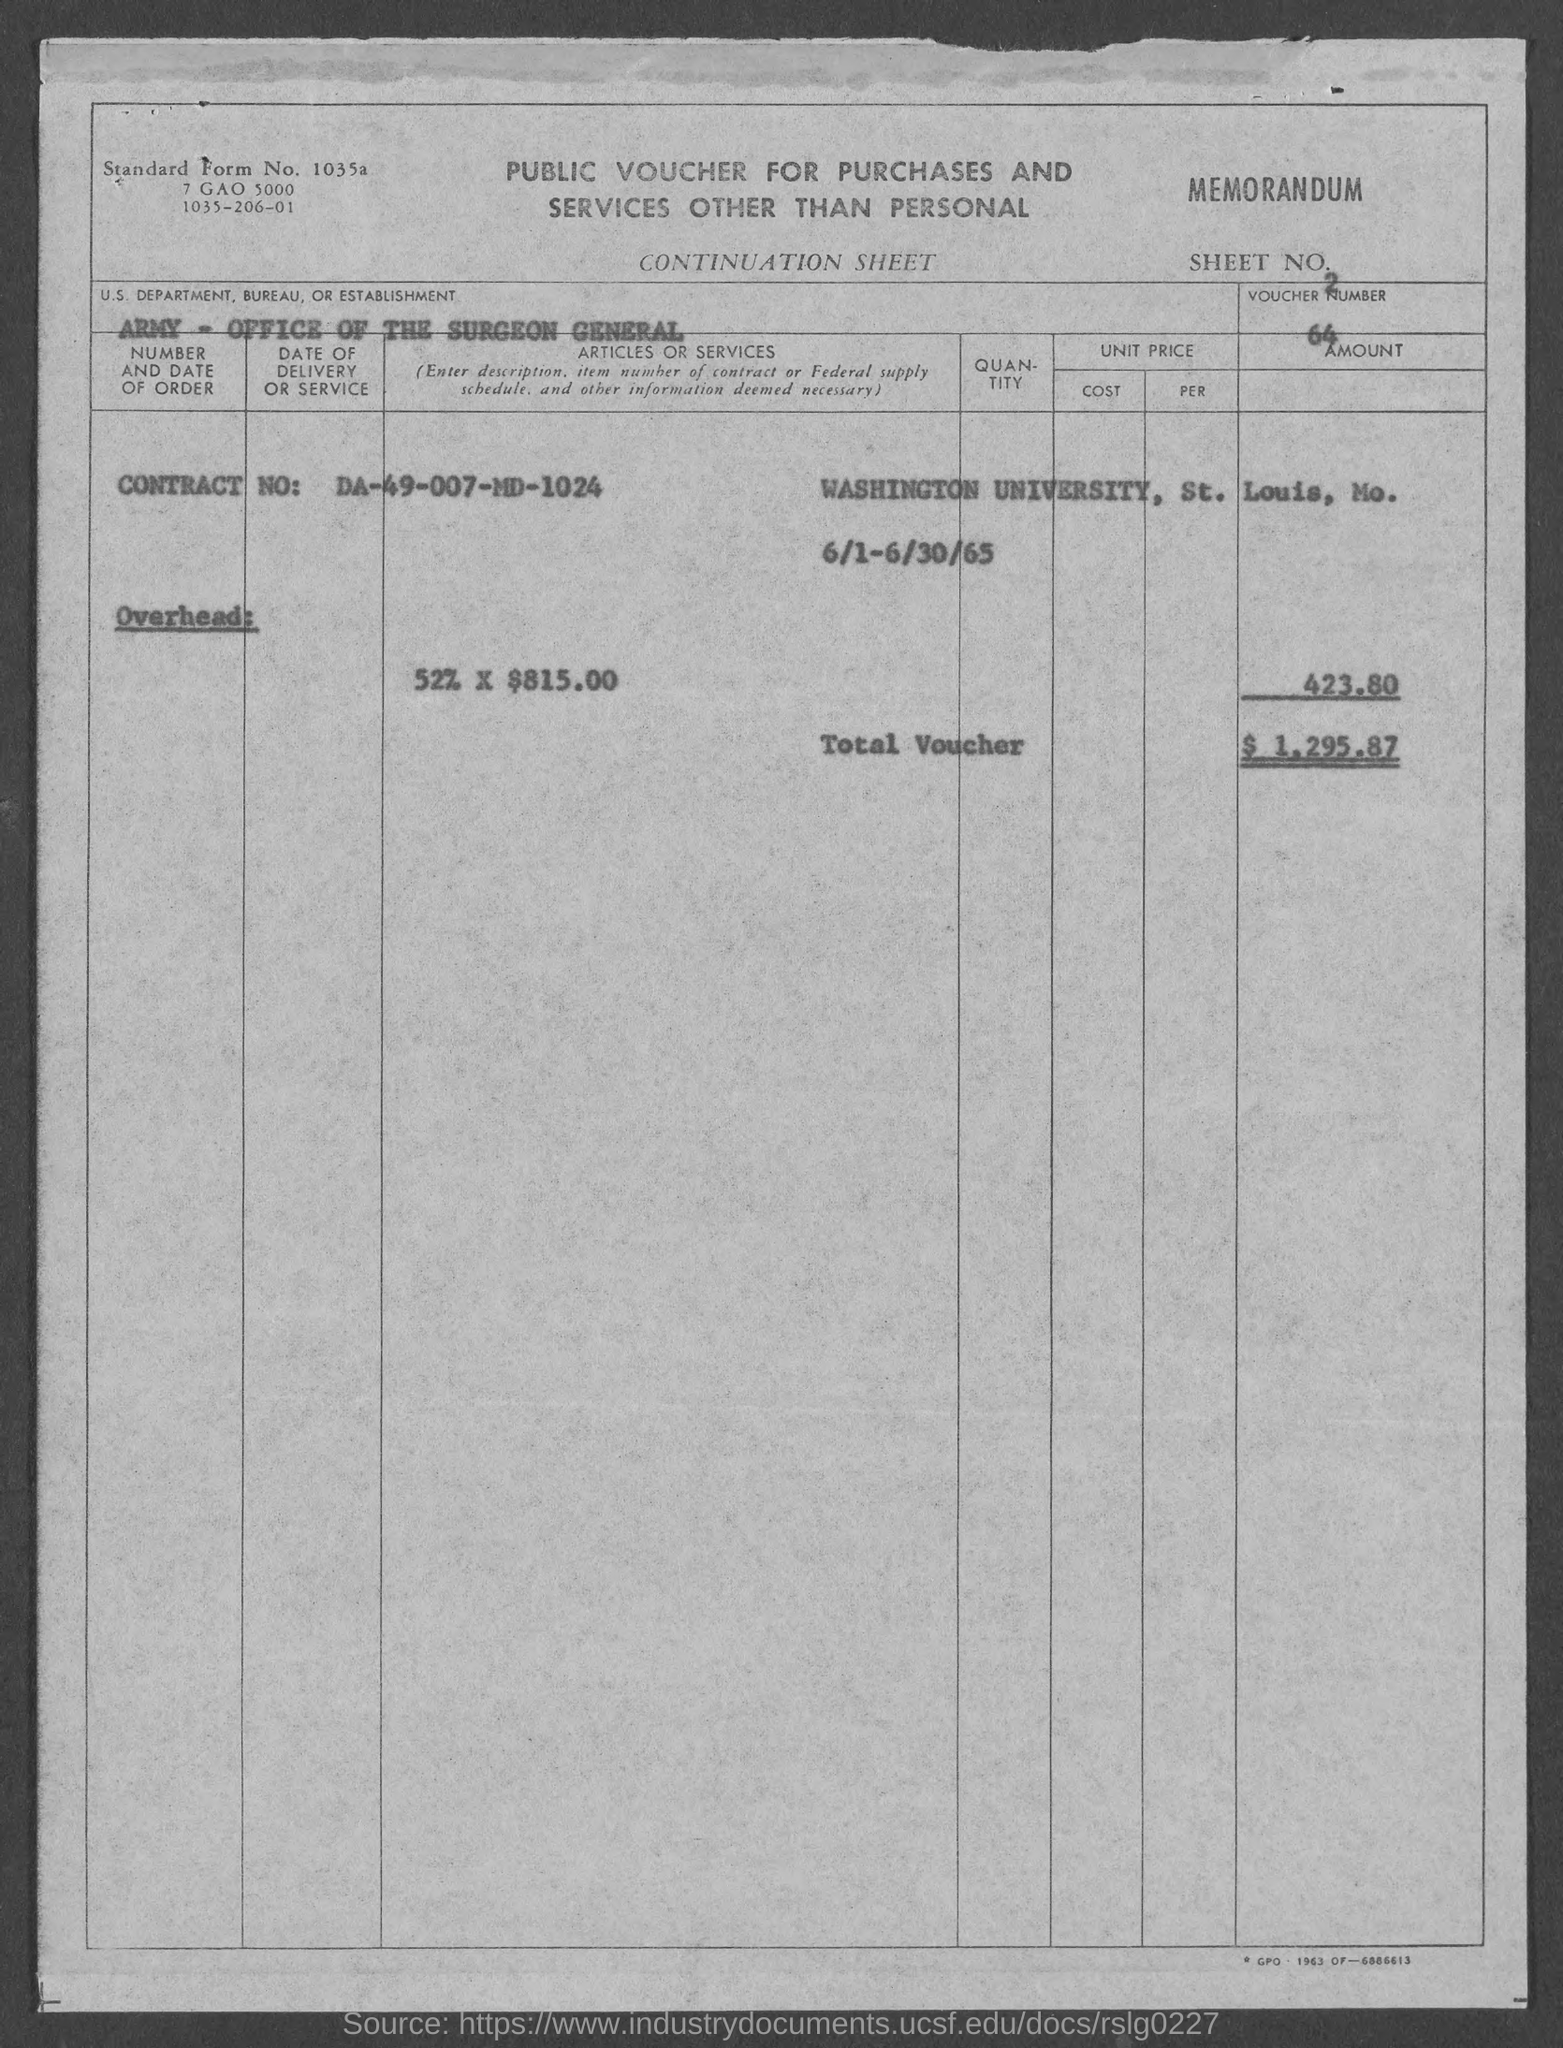Specify some key components in this picture. The total voucher amount is $1,295.87. The voucher number is 64. The Office of the Surgeon General of the US Army is a department, bureau, or establishment within the US Department, Bureau, or Establishment. 